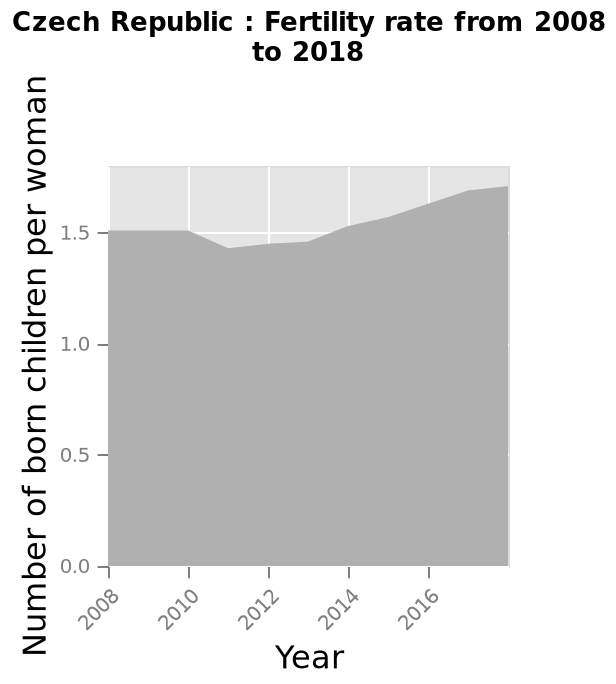<image>
please summary the statistics and relations of the chart from start to end there is an increase in fertility rate. this starts at 1.5 but there is a drop between 2010 and 2014 however this recovers and begins to increase. What is the label on the x-axis?  The label on the x-axis is Year. What is the time period covered by the graph? The graph covers the time period from 2008 to 2018. Describe the following image in detail This is a area graph called Czech Republic : Fertility rate from 2008 to 2018. A linear scale of range 2008 to 2016 can be found along the x-axis, labeled Year. Along the y-axis, Number of born children per woman is drawn. Is a logarithmic scale of range 2008 to 2016 found along the x-axis, labeled Year? No.This is a area graph called Czech Republic : Fertility rate from 2008 to 2018. A linear scale of range 2008 to 2016 can be found along the x-axis, labeled Year. Along the y-axis, Number of born children per woman is drawn. 